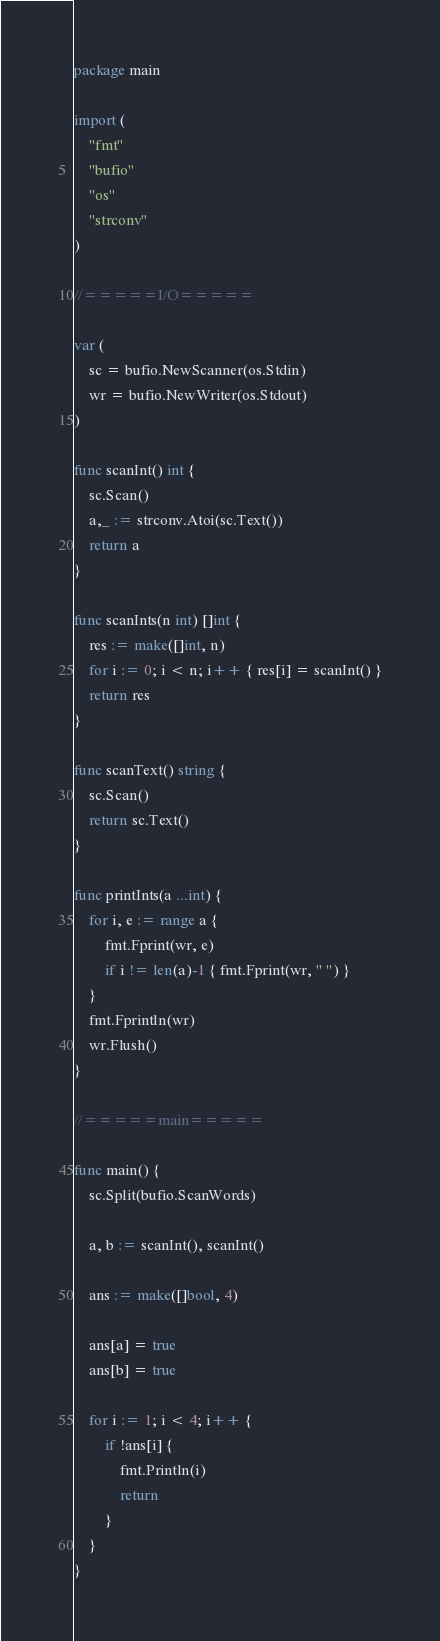<code> <loc_0><loc_0><loc_500><loc_500><_Go_>package main

import (
	"fmt"
	"bufio"
	"os"
	"strconv"
)

//=====I/O=====

var (
	sc = bufio.NewScanner(os.Stdin)
	wr = bufio.NewWriter(os.Stdout)
)

func scanInt() int {
	sc.Scan()
	a,_ := strconv.Atoi(sc.Text())
	return a
}

func scanInts(n int) []int {
	res := make([]int, n)
	for i := 0; i < n; i++ { res[i] = scanInt() }
	return res
}

func scanText() string {
	sc.Scan()
	return sc.Text()
}

func printInts(a ...int) {
	for i, e := range a {
		fmt.Fprint(wr, e)
		if i != len(a)-1 { fmt.Fprint(wr, " ") }
	}
	fmt.Fprintln(wr)
	wr.Flush()
}

//=====main=====

func main() {
	sc.Split(bufio.ScanWords)

	a, b := scanInt(), scanInt()

	ans := make([]bool, 4)

	ans[a] = true
	ans[b] = true

	for i := 1; i < 4; i++ {
		if !ans[i] {
			fmt.Println(i)
			return
		}
	}
}
</code> 